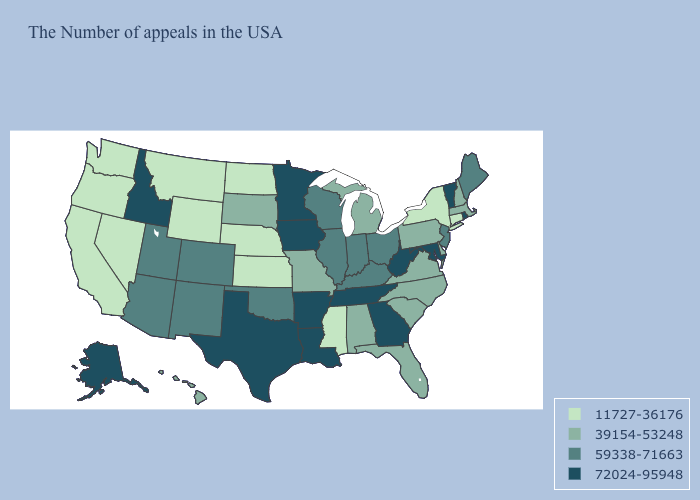Which states have the lowest value in the MidWest?
Be succinct. Kansas, Nebraska, North Dakota. Name the states that have a value in the range 72024-95948?
Keep it brief. Rhode Island, Vermont, Maryland, West Virginia, Georgia, Tennessee, Louisiana, Arkansas, Minnesota, Iowa, Texas, Idaho, Alaska. Among the states that border Wisconsin , which have the lowest value?
Be succinct. Michigan. Which states have the highest value in the USA?
Concise answer only. Rhode Island, Vermont, Maryland, West Virginia, Georgia, Tennessee, Louisiana, Arkansas, Minnesota, Iowa, Texas, Idaho, Alaska. Does the first symbol in the legend represent the smallest category?
Quick response, please. Yes. What is the value of Nevada?
Short answer required. 11727-36176. What is the value of South Carolina?
Be succinct. 39154-53248. Does Montana have the highest value in the West?
Be succinct. No. Does the first symbol in the legend represent the smallest category?
Be succinct. Yes. Which states have the lowest value in the Northeast?
Answer briefly. Connecticut, New York. What is the value of Nebraska?
Be succinct. 11727-36176. Does the first symbol in the legend represent the smallest category?
Write a very short answer. Yes. What is the highest value in the Northeast ?
Short answer required. 72024-95948. Among the states that border Arkansas , which have the lowest value?
Short answer required. Mississippi. 